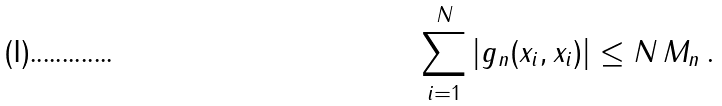Convert formula to latex. <formula><loc_0><loc_0><loc_500><loc_500>\sum _ { i = 1 } ^ { N } | g _ { n } ( x _ { i } , x _ { i } ) | \leq N \, M _ { n } \, .</formula> 